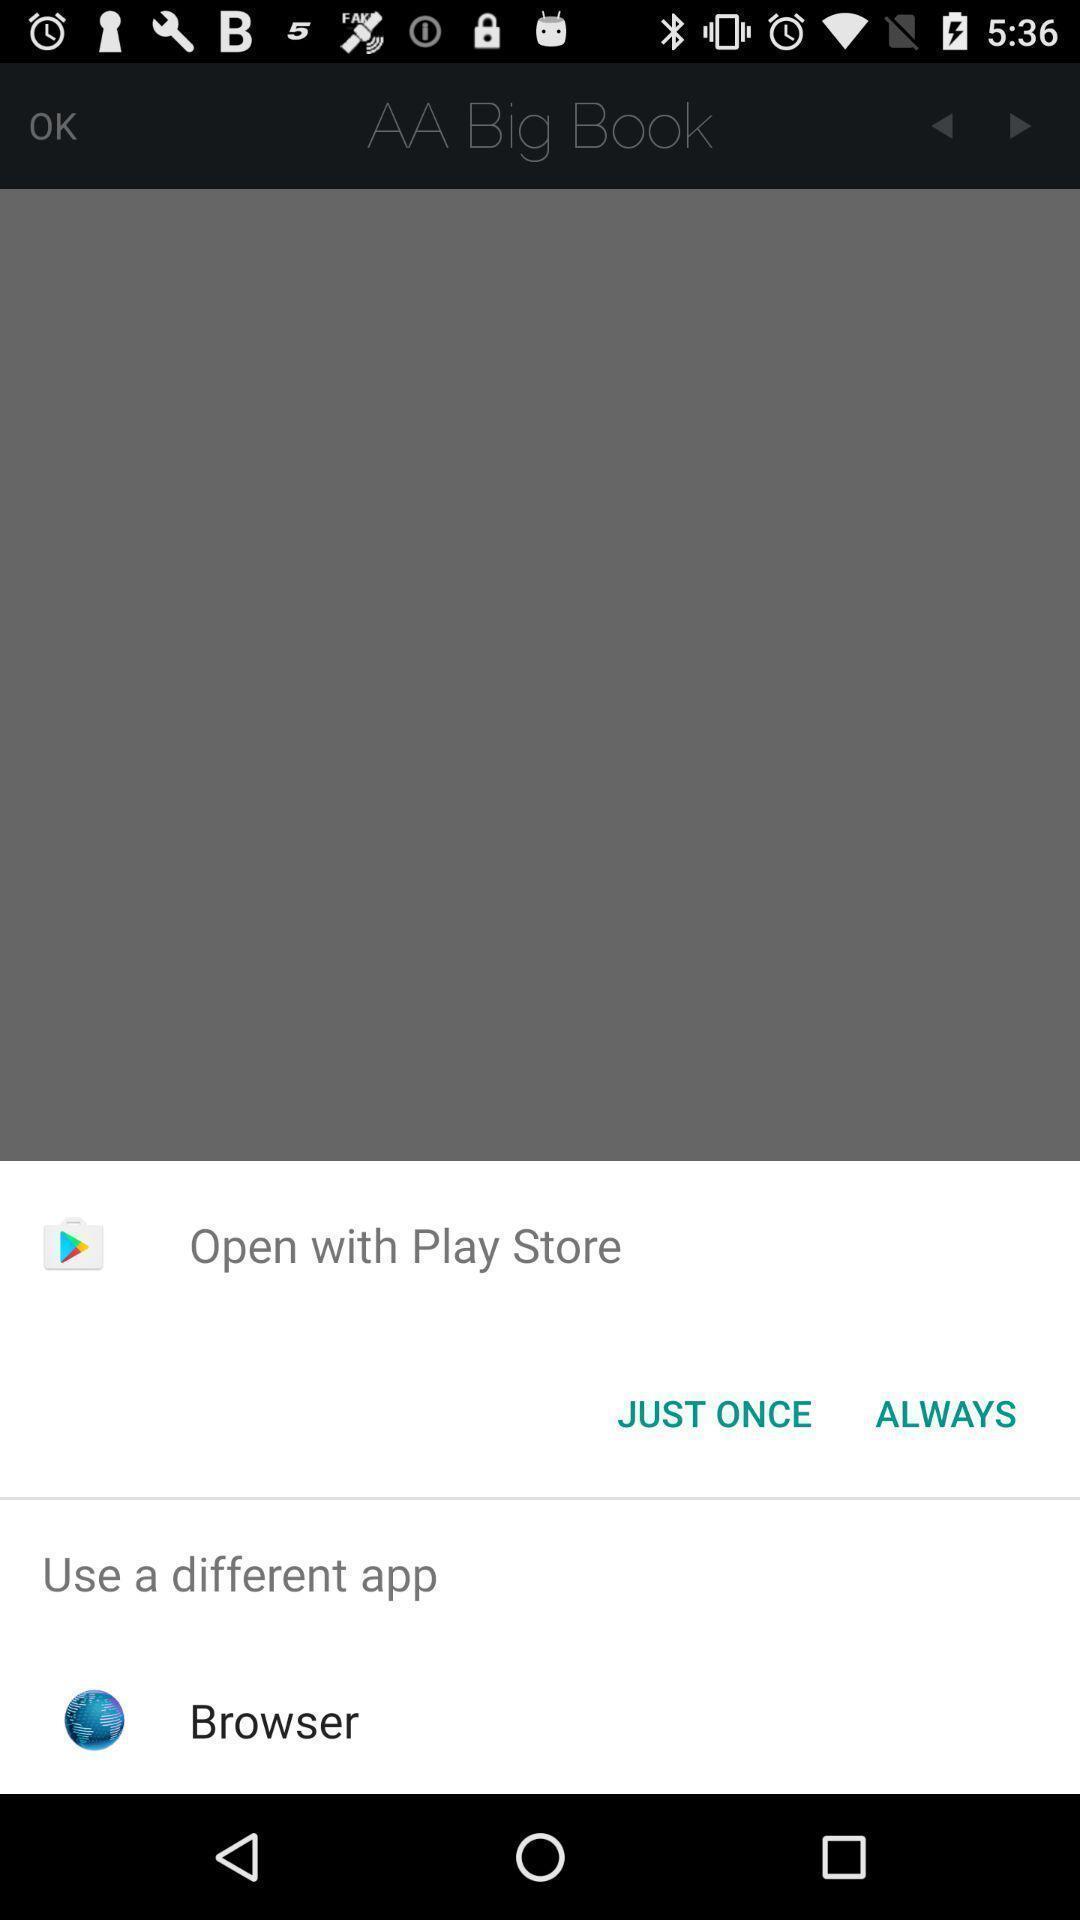What is the overall content of this screenshot? Pop-up showing multiple options to open. 